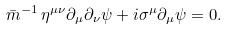Convert formula to latex. <formula><loc_0><loc_0><loc_500><loc_500>\bar { m } ^ { - 1 } \, \eta ^ { \mu \nu } \partial _ { \mu } \partial _ { \nu } \psi + i \sigma ^ { \mu } \partial _ { \mu } \psi = 0 .</formula> 